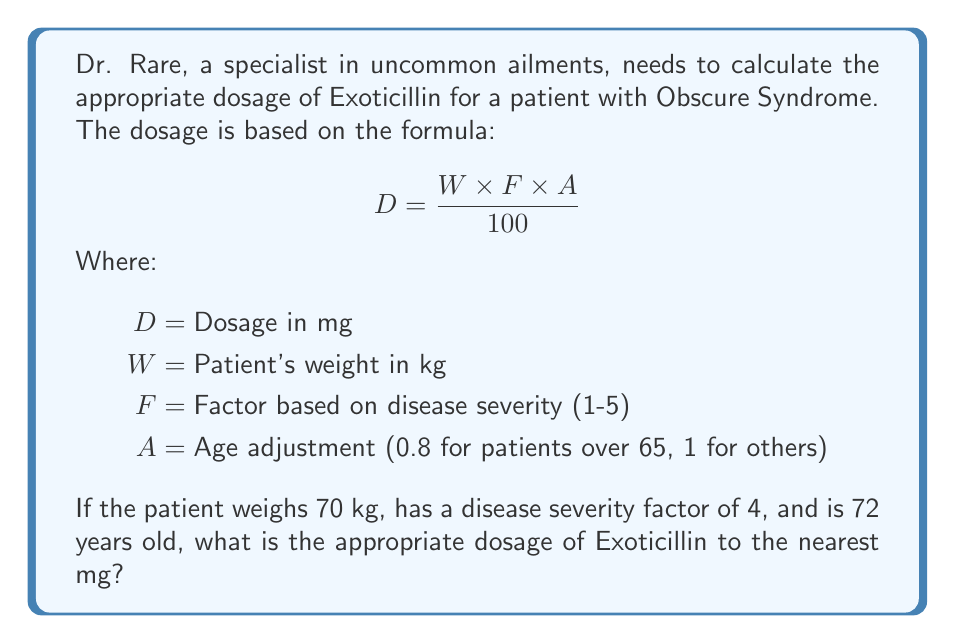What is the answer to this math problem? Let's approach this step-by-step:

1) We're given the formula: $$ D = \frac{W \times F \times A}{100} $$

2) We know the following values:
   $W = 70$ kg (patient's weight)
   $F = 4$ (disease severity factor)
   $A = 0.8$ (age adjustment, as the patient is over 65)

3) Let's substitute these values into the formula:

   $$ D = \frac{70 \times 4 \times 0.8}{100} $$

4) First, let's multiply the numerator:
   $70 \times 4 \times 0.8 = 224$

5) Now our equation looks like this:
   $$ D = \frac{224}{100} $$

6) Dividing 224 by 100:
   $D = 2.24$ mg

7) The question asks for the nearest mg, so we round 2.24 to 2 mg.
Answer: 2 mg 